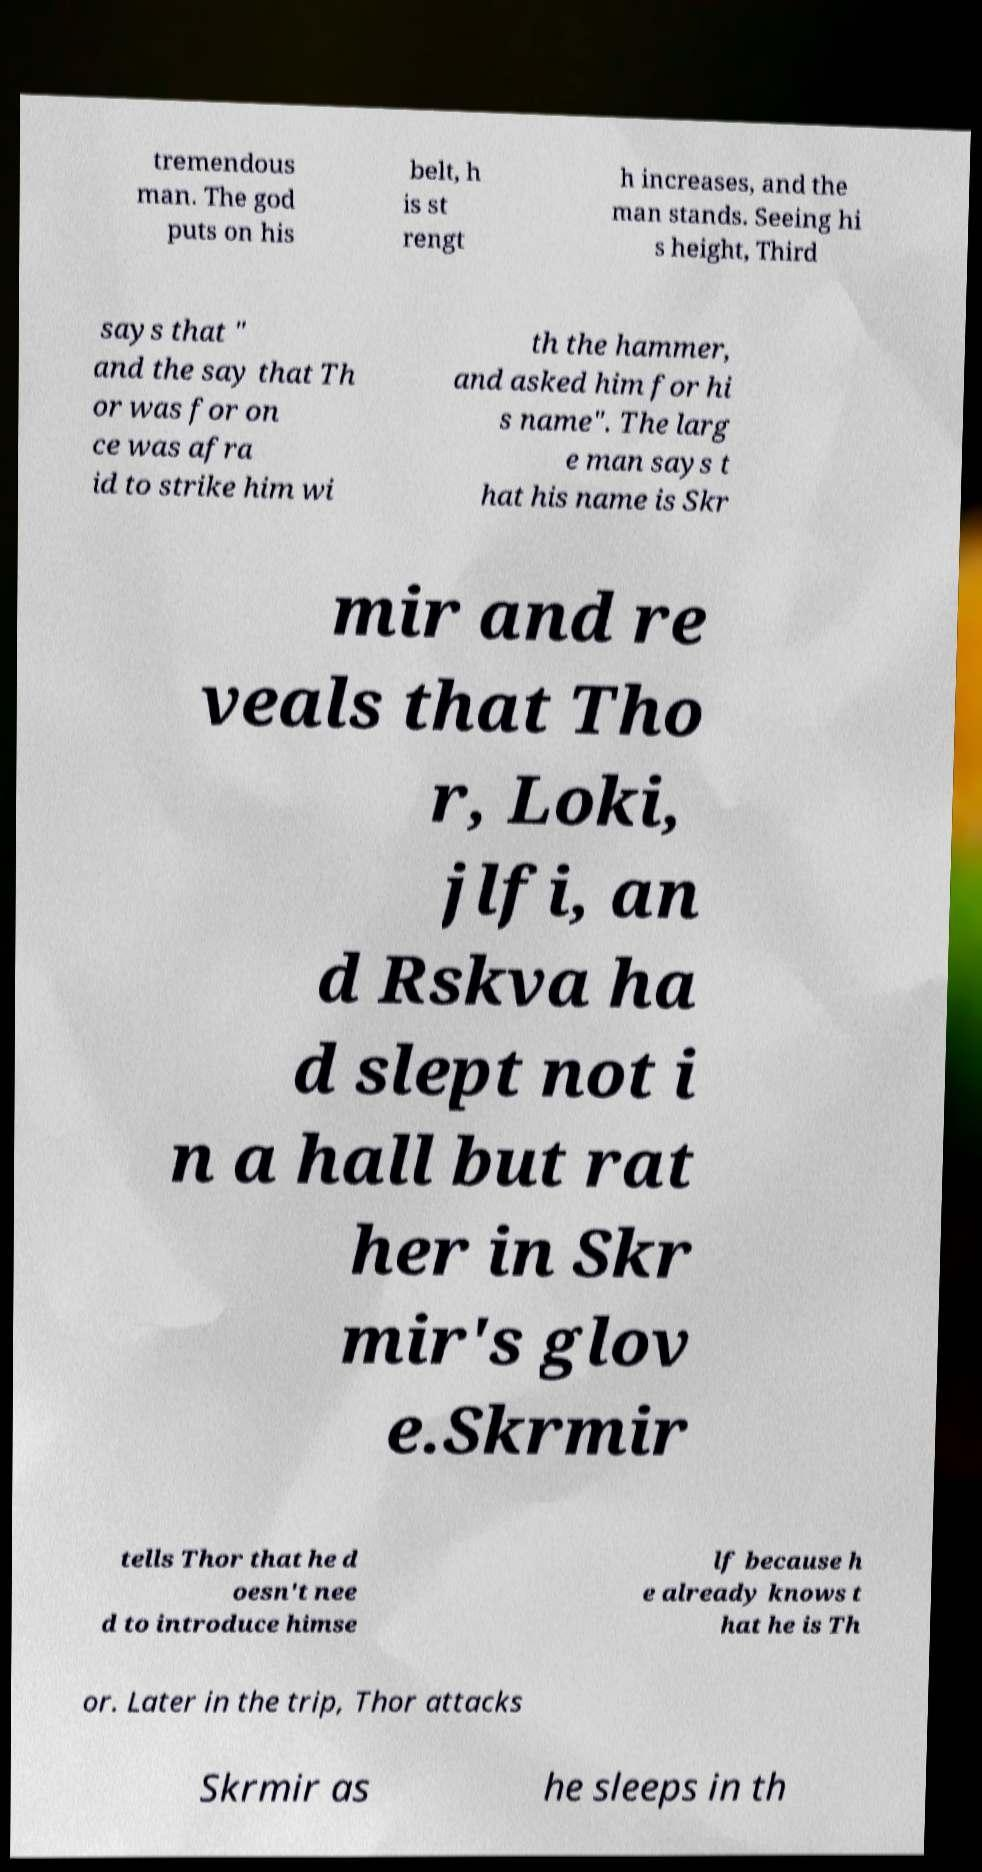I need the written content from this picture converted into text. Can you do that? tremendous man. The god puts on his belt, h is st rengt h increases, and the man stands. Seeing hi s height, Third says that " and the say that Th or was for on ce was afra id to strike him wi th the hammer, and asked him for hi s name". The larg e man says t hat his name is Skr mir and re veals that Tho r, Loki, jlfi, an d Rskva ha d slept not i n a hall but rat her in Skr mir's glov e.Skrmir tells Thor that he d oesn't nee d to introduce himse lf because h e already knows t hat he is Th or. Later in the trip, Thor attacks Skrmir as he sleeps in th 